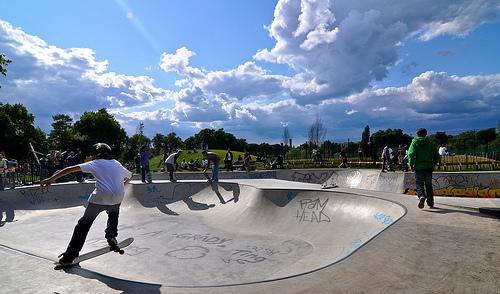Question: who is walking away?
Choices:
A. The man in the white shirt.
B. The woman in the pink shirt.
C. The boy in the green shirt.
D. The girl in the red shirt.
Answer with the letter. Answer: C Question: where is the boy in white?
Choices:
A. A baseball field.
B. Halloween party.
C. A skateboard park.
D. Church.
Answer with the letter. Answer: C Question: what is in the sky?
Choices:
A. Air.
B. Birds.
C. Clouds.
D. Airplanes.
Answer with the letter. Answer: C Question: what is the boy in white shirt doing?
Choices:
A. Listening to music.
B. Chatting with friends.
C. Singing.
D. Riding skateboard.
Answer with the letter. Answer: D 